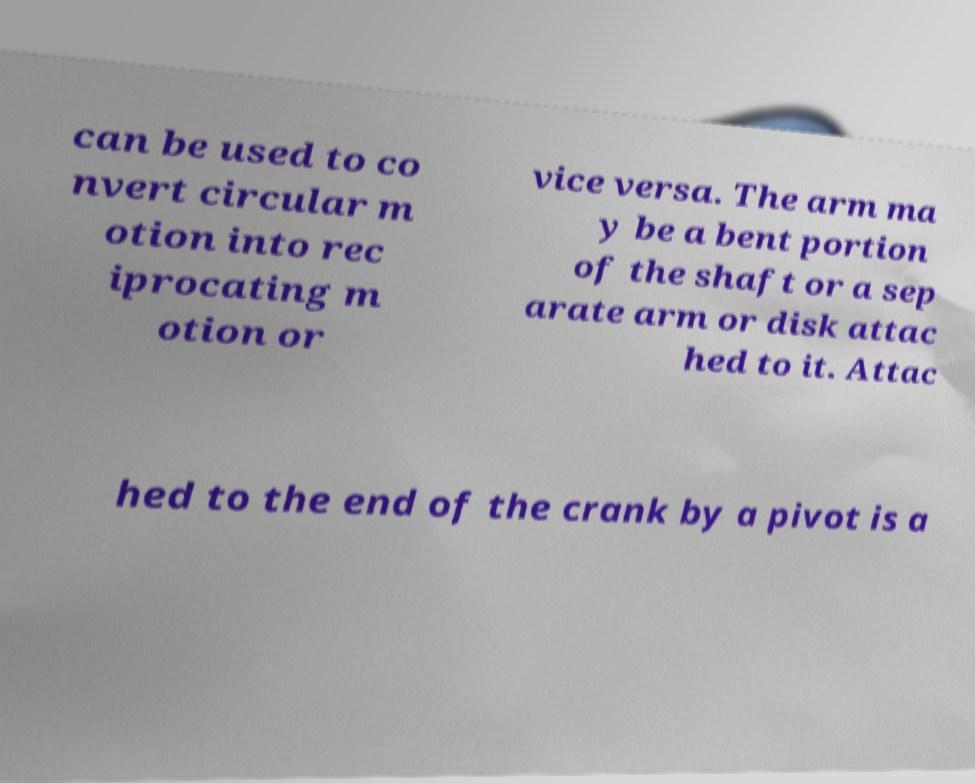Could you assist in decoding the text presented in this image and type it out clearly? can be used to co nvert circular m otion into rec iprocating m otion or vice versa. The arm ma y be a bent portion of the shaft or a sep arate arm or disk attac hed to it. Attac hed to the end of the crank by a pivot is a 